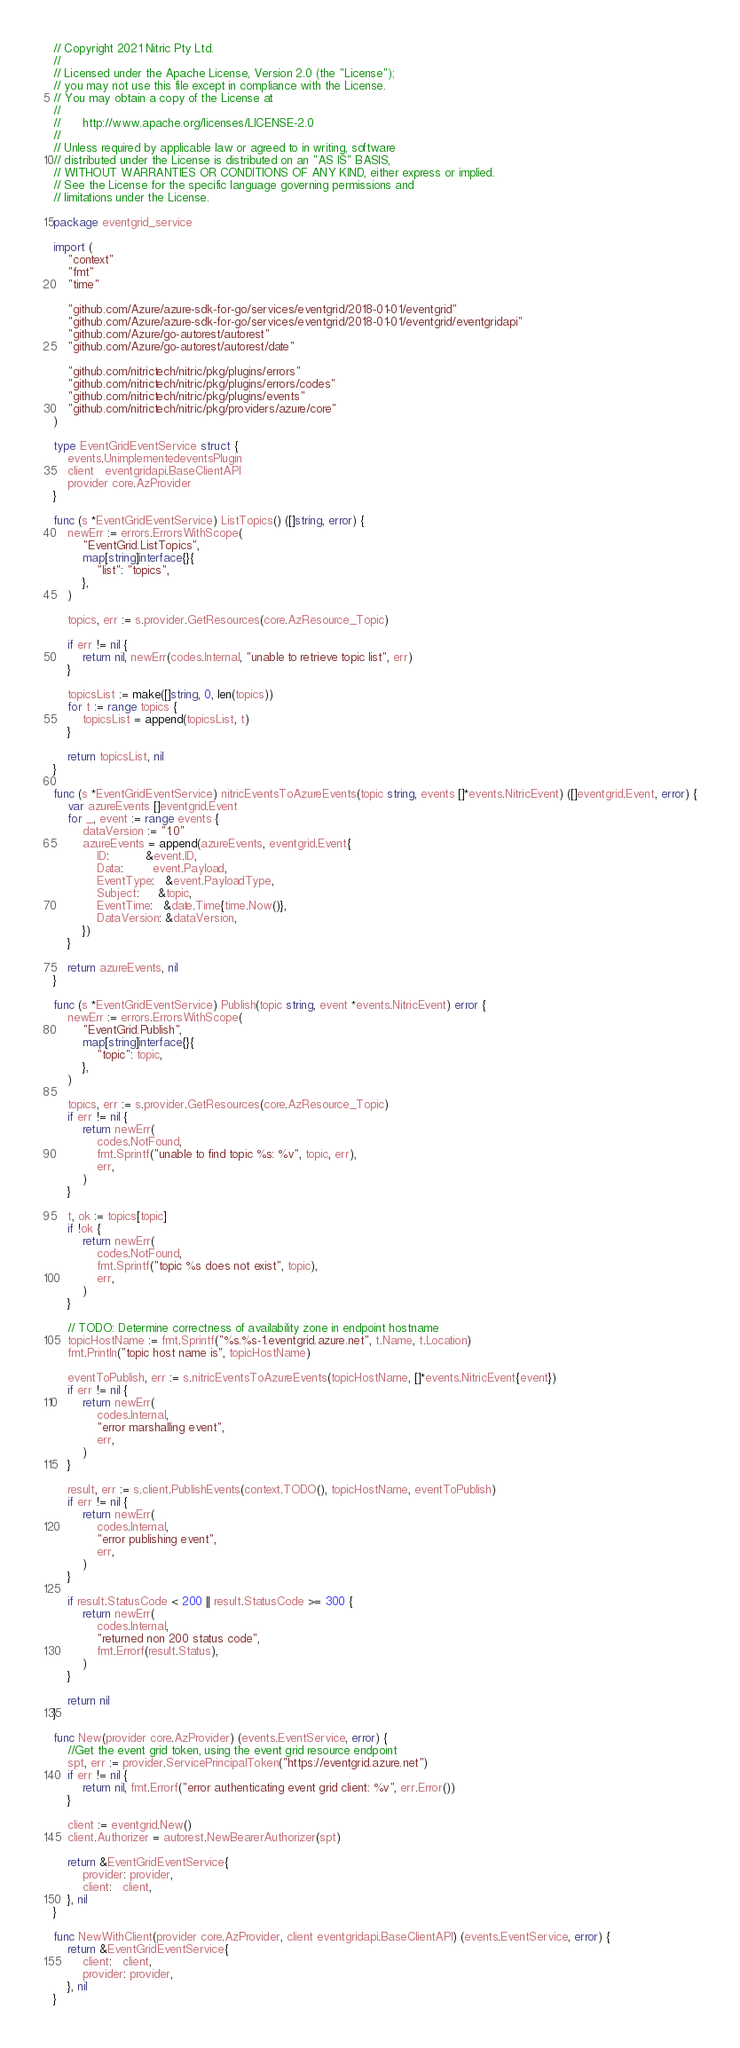<code> <loc_0><loc_0><loc_500><loc_500><_Go_>// Copyright 2021 Nitric Pty Ltd.
//
// Licensed under the Apache License, Version 2.0 (the "License");
// you may not use this file except in compliance with the License.
// You may obtain a copy of the License at
//
//      http://www.apache.org/licenses/LICENSE-2.0
//
// Unless required by applicable law or agreed to in writing, software
// distributed under the License is distributed on an "AS IS" BASIS,
// WITHOUT WARRANTIES OR CONDITIONS OF ANY KIND, either express or implied.
// See the License for the specific language governing permissions and
// limitations under the License.

package eventgrid_service

import (
	"context"
	"fmt"
	"time"

	"github.com/Azure/azure-sdk-for-go/services/eventgrid/2018-01-01/eventgrid"
	"github.com/Azure/azure-sdk-for-go/services/eventgrid/2018-01-01/eventgrid/eventgridapi"
	"github.com/Azure/go-autorest/autorest"
	"github.com/Azure/go-autorest/autorest/date"

	"github.com/nitrictech/nitric/pkg/plugins/errors"
	"github.com/nitrictech/nitric/pkg/plugins/errors/codes"
	"github.com/nitrictech/nitric/pkg/plugins/events"
	"github.com/nitrictech/nitric/pkg/providers/azure/core"
)

type EventGridEventService struct {
	events.UnimplementedeventsPlugin
	client   eventgridapi.BaseClientAPI
	provider core.AzProvider
}

func (s *EventGridEventService) ListTopics() ([]string, error) {
	newErr := errors.ErrorsWithScope(
		"EventGrid.ListTopics",
		map[string]interface{}{
			"list": "topics",
		},
	)

	topics, err := s.provider.GetResources(core.AzResource_Topic)

	if err != nil {
		return nil, newErr(codes.Internal, "unable to retrieve topic list", err)
	}

	topicsList := make([]string, 0, len(topics))
	for t := range topics {
		topicsList = append(topicsList, t)
	}

	return topicsList, nil
}

func (s *EventGridEventService) nitricEventsToAzureEvents(topic string, events []*events.NitricEvent) ([]eventgrid.Event, error) {
	var azureEvents []eventgrid.Event
	for _, event := range events {
		dataVersion := "1.0"
		azureEvents = append(azureEvents, eventgrid.Event{
			ID:          &event.ID,
			Data:        event.Payload,
			EventType:   &event.PayloadType,
			Subject:     &topic,
			EventTime:   &date.Time{time.Now()},
			DataVersion: &dataVersion,
		})
	}

	return azureEvents, nil
}

func (s *EventGridEventService) Publish(topic string, event *events.NitricEvent) error {
	newErr := errors.ErrorsWithScope(
		"EventGrid.Publish",
		map[string]interface{}{
			"topic": topic,
		},
	)

	topics, err := s.provider.GetResources(core.AzResource_Topic)
	if err != nil {
		return newErr(
			codes.NotFound,
			fmt.Sprintf("unable to find topic %s: %v", topic, err),
			err,
		)
	}

	t, ok := topics[topic]
	if !ok {
		return newErr(
			codes.NotFound,
			fmt.Sprintf("topic %s does not exist", topic),
			err,
		)
	}

	// TODO: Determine correctness of availability zone in endpoint hostname
	topicHostName := fmt.Sprintf("%s.%s-1.eventgrid.azure.net", t.Name, t.Location)
	fmt.Println("topic host name is", topicHostName)

	eventToPublish, err := s.nitricEventsToAzureEvents(topicHostName, []*events.NitricEvent{event})
	if err != nil {
		return newErr(
			codes.Internal,
			"error marshalling event",
			err,
		)
	}

	result, err := s.client.PublishEvents(context.TODO(), topicHostName, eventToPublish)
	if err != nil {
		return newErr(
			codes.Internal,
			"error publishing event",
			err,
		)
	}

	if result.StatusCode < 200 || result.StatusCode >= 300 {
		return newErr(
			codes.Internal,
			"returned non 200 status code",
			fmt.Errorf(result.Status),
		)
	}

	return nil
}

func New(provider core.AzProvider) (events.EventService, error) {
	//Get the event grid token, using the event grid resource endpoint
	spt, err := provider.ServicePrincipalToken("https://eventgrid.azure.net")
	if err != nil {
		return nil, fmt.Errorf("error authenticating event grid client: %v", err.Error())
	}

	client := eventgrid.New()
	client.Authorizer = autorest.NewBearerAuthorizer(spt)

	return &EventGridEventService{
		provider: provider,
		client:   client,
	}, nil
}

func NewWithClient(provider core.AzProvider, client eventgridapi.BaseClientAPI) (events.EventService, error) {
	return &EventGridEventService{
		client:   client,
		provider: provider,
	}, nil
}
</code> 